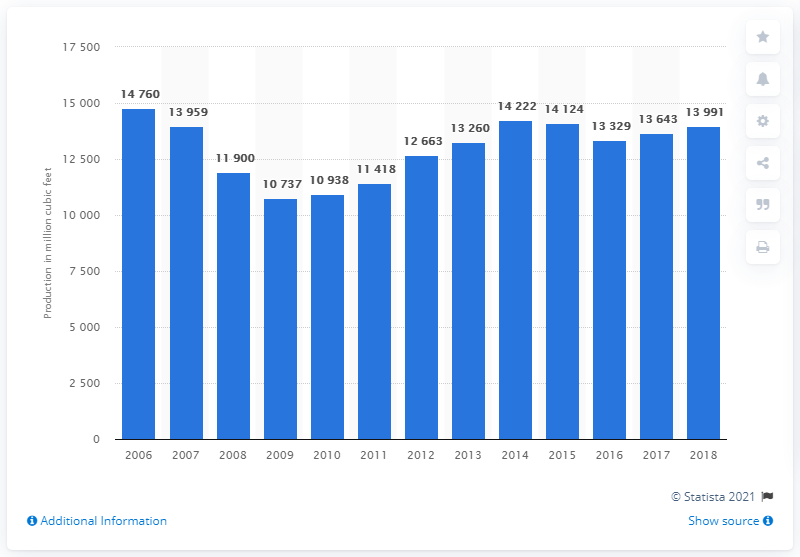Mention a couple of crucial points in this snapshot. In 2018, the total amount of industrial roundwood production in the United States was 13,991.. 